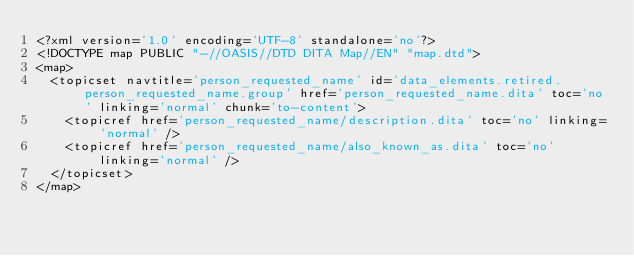<code> <loc_0><loc_0><loc_500><loc_500><_XML_><?xml version='1.0' encoding='UTF-8' standalone='no'?>
<!DOCTYPE map PUBLIC "-//OASIS//DTD DITA Map//EN" "map.dtd">
<map>
  <topicset navtitle='person_requested_name' id='data_elements.retired.person_requested_name.group' href='person_requested_name.dita' toc='no' linking='normal' chunk='to-content'>
    <topicref href='person_requested_name/description.dita' toc='no' linking='normal' />
    <topicref href='person_requested_name/also_known_as.dita' toc='no' linking='normal' />
  </topicset>
</map></code> 